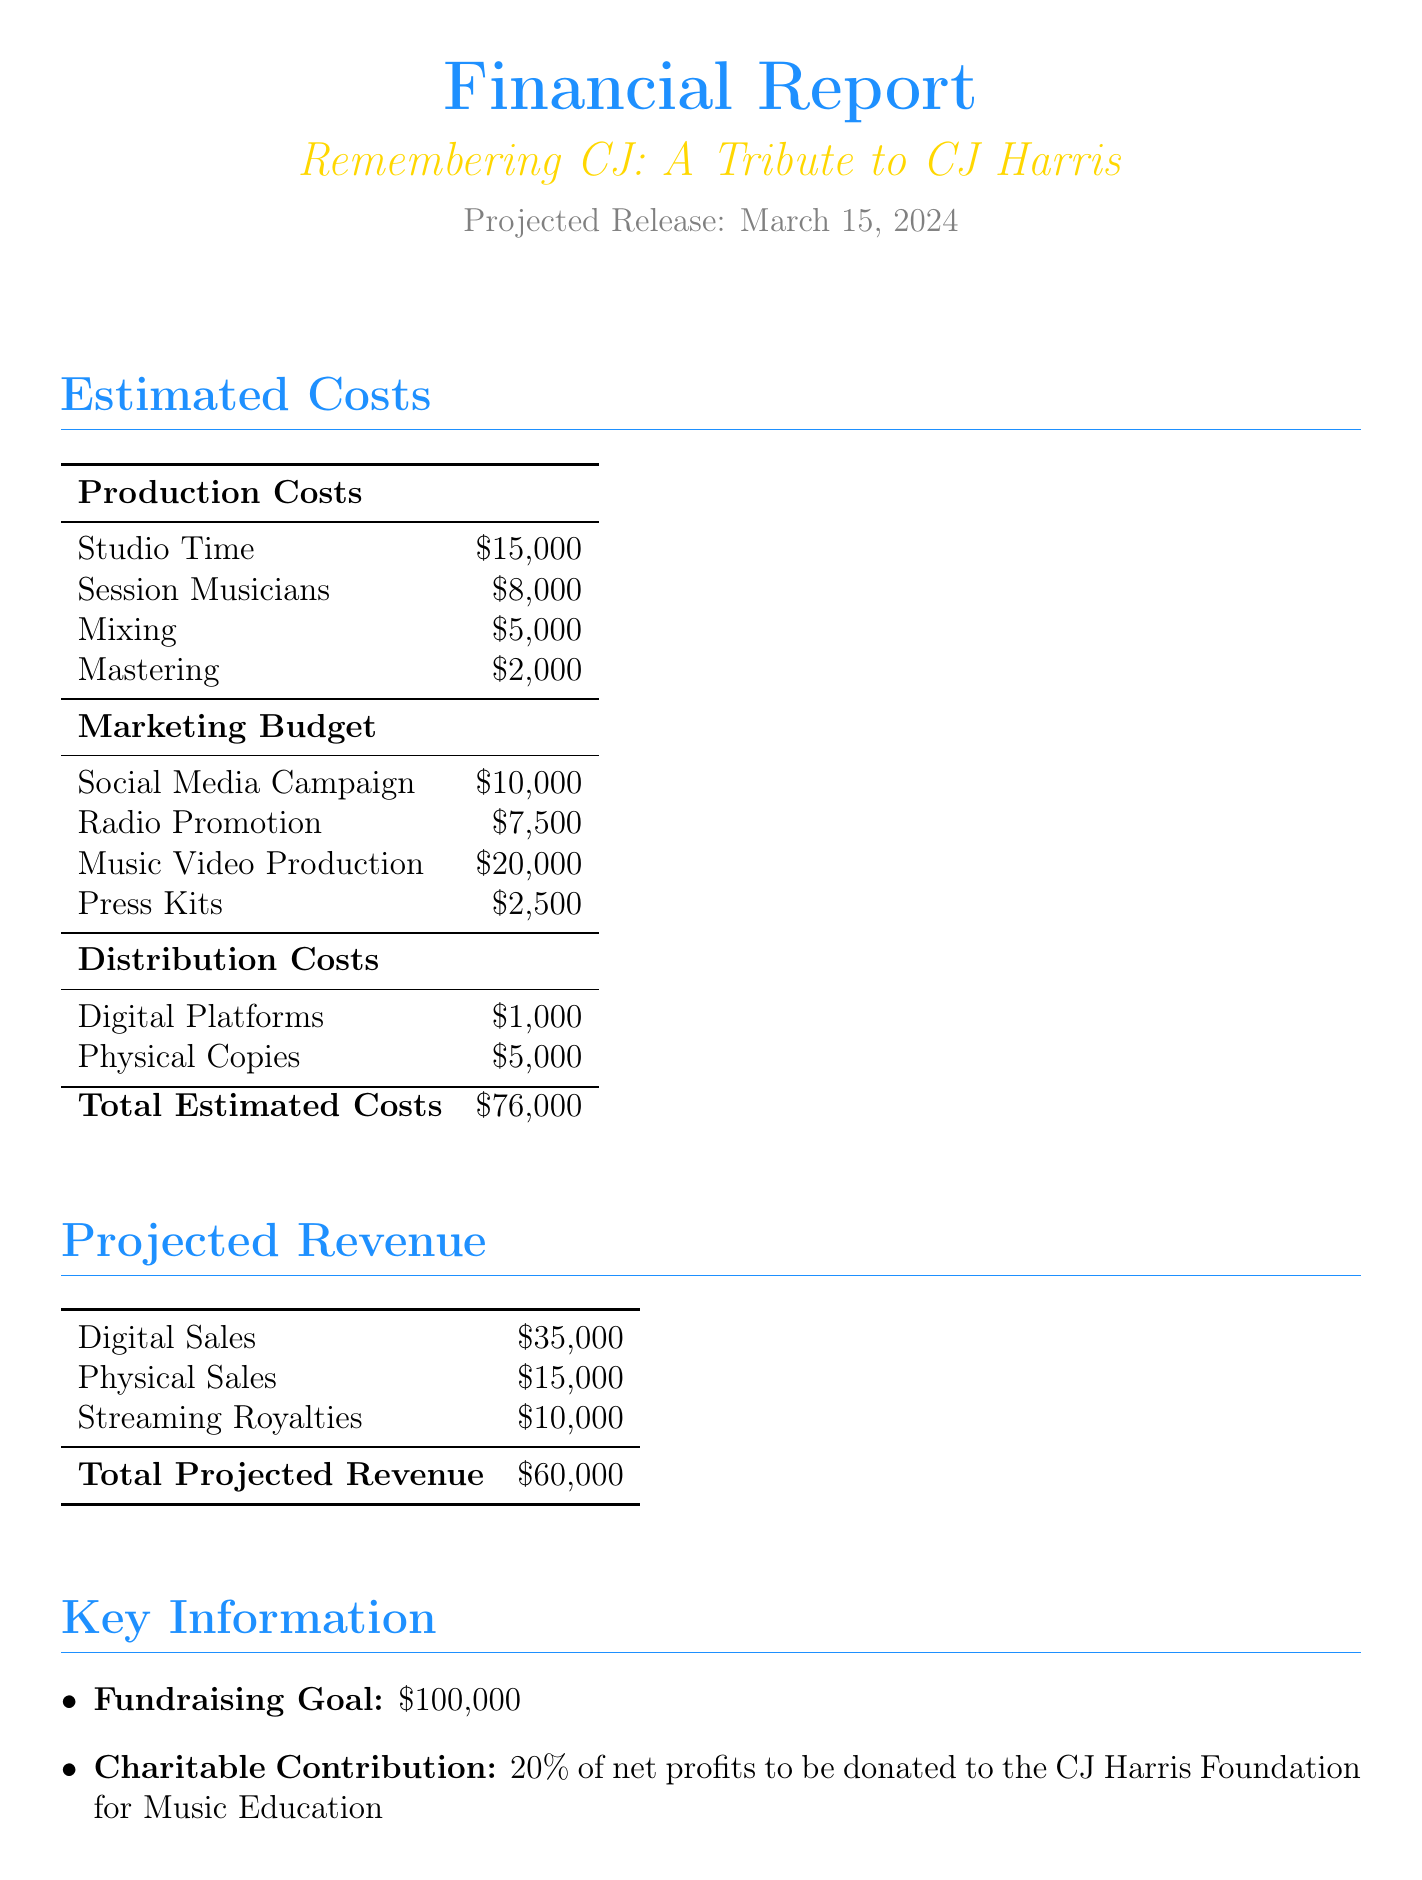What is the title of the tribute album? The title of the tribute album is explicitly stated in the document.
Answer: Remembering CJ: A Tribute to CJ Harris What is the projected release date? The document provides the specific date for the projected release.
Answer: March 15, 2024 What is the total estimated production cost? The total production cost is calculated by summing all production-related expenses listed in the document.
Answer: $76,000 What is the fundraising goal? The document mentions the goal amount intended to be raised for the album.
Answer: $100,000 What percentage of net profits will be donated? The document specifies the percentage that will be contributed to the foundation.
Answer: 20% Who are the key collaborators? The document lists the names of the key artists involved in the tribute album.
Answer: Katy Perry, Lionel Richie, Luke Bryan What is the total projected revenue? The total projected revenue is obtained by adding all revenue sources provided in the document.
Answer: $60,000 What is included in the marketing budget? The document outlines items in the marketing budget, specifically social media campaign, radio promotion, music video production, and press kits.
Answer: Social Media Campaign, Radio Promotion, Music Video Production, Press Kits What type of album is being created? The document indicates the nature of the album's purpose.
Answer: Tribute Album 